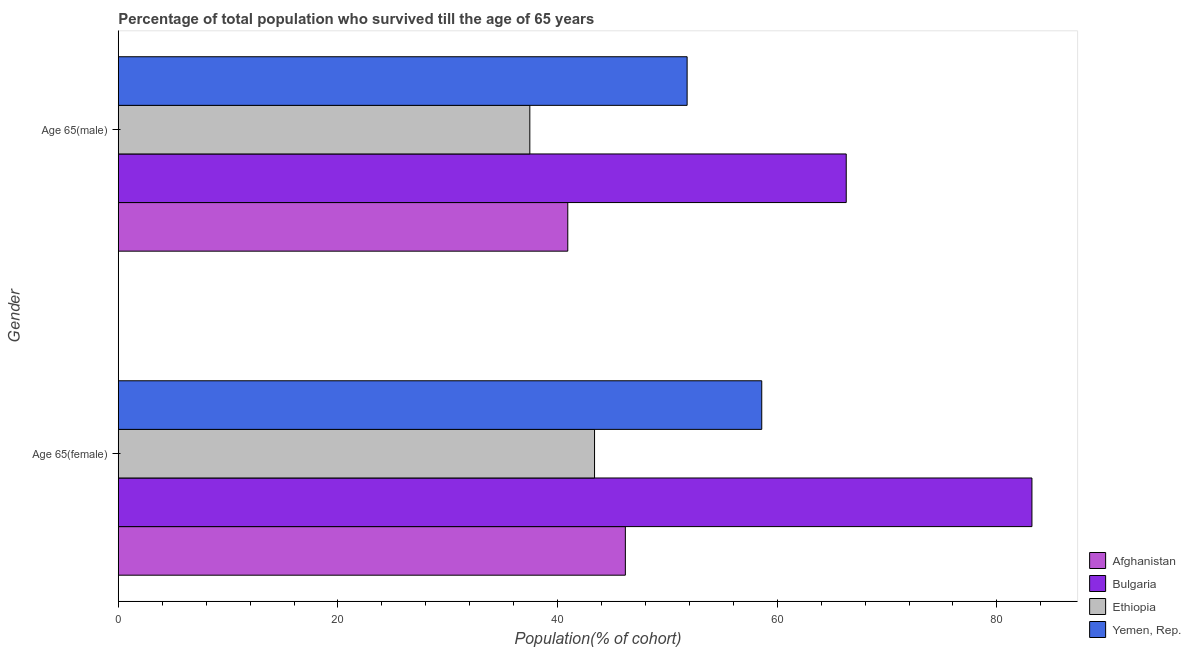How many bars are there on the 1st tick from the top?
Provide a short and direct response. 4. What is the label of the 1st group of bars from the top?
Provide a succinct answer. Age 65(male). What is the percentage of male population who survived till age of 65 in Yemen, Rep.?
Offer a very short reply. 51.8. Across all countries, what is the maximum percentage of male population who survived till age of 65?
Keep it short and to the point. 66.28. Across all countries, what is the minimum percentage of male population who survived till age of 65?
Provide a short and direct response. 37.47. In which country was the percentage of male population who survived till age of 65 minimum?
Keep it short and to the point. Ethiopia. What is the total percentage of male population who survived till age of 65 in the graph?
Offer a very short reply. 196.48. What is the difference between the percentage of male population who survived till age of 65 in Yemen, Rep. and that in Afghanistan?
Provide a succinct answer. 10.87. What is the difference between the percentage of male population who survived till age of 65 in Yemen, Rep. and the percentage of female population who survived till age of 65 in Bulgaria?
Keep it short and to the point. -31.4. What is the average percentage of female population who survived till age of 65 per country?
Offer a terse response. 57.83. What is the difference between the percentage of female population who survived till age of 65 and percentage of male population who survived till age of 65 in Yemen, Rep.?
Your answer should be compact. 6.8. What is the ratio of the percentage of male population who survived till age of 65 in Yemen, Rep. to that in Afghanistan?
Offer a terse response. 1.27. In how many countries, is the percentage of female population who survived till age of 65 greater than the average percentage of female population who survived till age of 65 taken over all countries?
Your answer should be compact. 2. What does the 1st bar from the top in Age 65(male) represents?
Provide a succinct answer. Yemen, Rep. What does the 4th bar from the bottom in Age 65(female) represents?
Make the answer very short. Yemen, Rep. How many bars are there?
Your answer should be very brief. 8. Are all the bars in the graph horizontal?
Keep it short and to the point. Yes. How many countries are there in the graph?
Provide a short and direct response. 4. What is the difference between two consecutive major ticks on the X-axis?
Provide a succinct answer. 20. Does the graph contain any zero values?
Your response must be concise. No. Does the graph contain grids?
Offer a very short reply. No. Where does the legend appear in the graph?
Your response must be concise. Bottom right. How many legend labels are there?
Offer a very short reply. 4. How are the legend labels stacked?
Your answer should be compact. Vertical. What is the title of the graph?
Your answer should be compact. Percentage of total population who survived till the age of 65 years. What is the label or title of the X-axis?
Ensure brevity in your answer.  Population(% of cohort). What is the Population(% of cohort) in Afghanistan in Age 65(female)?
Provide a succinct answer. 46.17. What is the Population(% of cohort) in Bulgaria in Age 65(female)?
Give a very brief answer. 83.19. What is the Population(% of cohort) in Ethiopia in Age 65(female)?
Your response must be concise. 43.37. What is the Population(% of cohort) in Yemen, Rep. in Age 65(female)?
Your response must be concise. 58.59. What is the Population(% of cohort) of Afghanistan in Age 65(male)?
Provide a short and direct response. 40.93. What is the Population(% of cohort) in Bulgaria in Age 65(male)?
Ensure brevity in your answer.  66.28. What is the Population(% of cohort) of Ethiopia in Age 65(male)?
Give a very brief answer. 37.47. What is the Population(% of cohort) in Yemen, Rep. in Age 65(male)?
Ensure brevity in your answer.  51.8. Across all Gender, what is the maximum Population(% of cohort) in Afghanistan?
Provide a short and direct response. 46.17. Across all Gender, what is the maximum Population(% of cohort) of Bulgaria?
Give a very brief answer. 83.19. Across all Gender, what is the maximum Population(% of cohort) of Ethiopia?
Your response must be concise. 43.37. Across all Gender, what is the maximum Population(% of cohort) of Yemen, Rep.?
Your response must be concise. 58.59. Across all Gender, what is the minimum Population(% of cohort) of Afghanistan?
Keep it short and to the point. 40.93. Across all Gender, what is the minimum Population(% of cohort) in Bulgaria?
Offer a very short reply. 66.28. Across all Gender, what is the minimum Population(% of cohort) in Ethiopia?
Keep it short and to the point. 37.47. Across all Gender, what is the minimum Population(% of cohort) in Yemen, Rep.?
Ensure brevity in your answer.  51.8. What is the total Population(% of cohort) of Afghanistan in the graph?
Give a very brief answer. 87.1. What is the total Population(% of cohort) of Bulgaria in the graph?
Your answer should be compact. 149.48. What is the total Population(% of cohort) of Ethiopia in the graph?
Provide a short and direct response. 80.84. What is the total Population(% of cohort) of Yemen, Rep. in the graph?
Offer a terse response. 110.39. What is the difference between the Population(% of cohort) in Afghanistan in Age 65(female) and that in Age 65(male)?
Your answer should be very brief. 5.24. What is the difference between the Population(% of cohort) of Bulgaria in Age 65(female) and that in Age 65(male)?
Your answer should be very brief. 16.91. What is the difference between the Population(% of cohort) of Ethiopia in Age 65(female) and that in Age 65(male)?
Your answer should be compact. 5.89. What is the difference between the Population(% of cohort) of Yemen, Rep. in Age 65(female) and that in Age 65(male)?
Ensure brevity in your answer.  6.8. What is the difference between the Population(% of cohort) of Afghanistan in Age 65(female) and the Population(% of cohort) of Bulgaria in Age 65(male)?
Offer a very short reply. -20.11. What is the difference between the Population(% of cohort) of Afghanistan in Age 65(female) and the Population(% of cohort) of Ethiopia in Age 65(male)?
Offer a terse response. 8.7. What is the difference between the Population(% of cohort) in Afghanistan in Age 65(female) and the Population(% of cohort) in Yemen, Rep. in Age 65(male)?
Offer a very short reply. -5.62. What is the difference between the Population(% of cohort) in Bulgaria in Age 65(female) and the Population(% of cohort) in Ethiopia in Age 65(male)?
Keep it short and to the point. 45.72. What is the difference between the Population(% of cohort) of Bulgaria in Age 65(female) and the Population(% of cohort) of Yemen, Rep. in Age 65(male)?
Provide a succinct answer. 31.4. What is the difference between the Population(% of cohort) in Ethiopia in Age 65(female) and the Population(% of cohort) in Yemen, Rep. in Age 65(male)?
Ensure brevity in your answer.  -8.43. What is the average Population(% of cohort) of Afghanistan per Gender?
Keep it short and to the point. 43.55. What is the average Population(% of cohort) of Bulgaria per Gender?
Your answer should be compact. 74.74. What is the average Population(% of cohort) of Ethiopia per Gender?
Keep it short and to the point. 40.42. What is the average Population(% of cohort) in Yemen, Rep. per Gender?
Your answer should be very brief. 55.19. What is the difference between the Population(% of cohort) of Afghanistan and Population(% of cohort) of Bulgaria in Age 65(female)?
Offer a very short reply. -37.02. What is the difference between the Population(% of cohort) of Afghanistan and Population(% of cohort) of Ethiopia in Age 65(female)?
Your answer should be very brief. 2.8. What is the difference between the Population(% of cohort) in Afghanistan and Population(% of cohort) in Yemen, Rep. in Age 65(female)?
Your answer should be compact. -12.42. What is the difference between the Population(% of cohort) in Bulgaria and Population(% of cohort) in Ethiopia in Age 65(female)?
Provide a succinct answer. 39.83. What is the difference between the Population(% of cohort) of Bulgaria and Population(% of cohort) of Yemen, Rep. in Age 65(female)?
Keep it short and to the point. 24.6. What is the difference between the Population(% of cohort) in Ethiopia and Population(% of cohort) in Yemen, Rep. in Age 65(female)?
Provide a succinct answer. -15.22. What is the difference between the Population(% of cohort) in Afghanistan and Population(% of cohort) in Bulgaria in Age 65(male)?
Your answer should be compact. -25.36. What is the difference between the Population(% of cohort) of Afghanistan and Population(% of cohort) of Ethiopia in Age 65(male)?
Give a very brief answer. 3.46. What is the difference between the Population(% of cohort) of Afghanistan and Population(% of cohort) of Yemen, Rep. in Age 65(male)?
Give a very brief answer. -10.87. What is the difference between the Population(% of cohort) of Bulgaria and Population(% of cohort) of Ethiopia in Age 65(male)?
Your answer should be very brief. 28.81. What is the difference between the Population(% of cohort) in Bulgaria and Population(% of cohort) in Yemen, Rep. in Age 65(male)?
Your answer should be compact. 14.49. What is the difference between the Population(% of cohort) of Ethiopia and Population(% of cohort) of Yemen, Rep. in Age 65(male)?
Your answer should be very brief. -14.32. What is the ratio of the Population(% of cohort) in Afghanistan in Age 65(female) to that in Age 65(male)?
Your response must be concise. 1.13. What is the ratio of the Population(% of cohort) in Bulgaria in Age 65(female) to that in Age 65(male)?
Your answer should be compact. 1.26. What is the ratio of the Population(% of cohort) in Ethiopia in Age 65(female) to that in Age 65(male)?
Provide a short and direct response. 1.16. What is the ratio of the Population(% of cohort) in Yemen, Rep. in Age 65(female) to that in Age 65(male)?
Provide a short and direct response. 1.13. What is the difference between the highest and the second highest Population(% of cohort) of Afghanistan?
Make the answer very short. 5.24. What is the difference between the highest and the second highest Population(% of cohort) in Bulgaria?
Make the answer very short. 16.91. What is the difference between the highest and the second highest Population(% of cohort) of Ethiopia?
Your response must be concise. 5.89. What is the difference between the highest and the second highest Population(% of cohort) in Yemen, Rep.?
Your answer should be very brief. 6.8. What is the difference between the highest and the lowest Population(% of cohort) of Afghanistan?
Offer a very short reply. 5.24. What is the difference between the highest and the lowest Population(% of cohort) of Bulgaria?
Your answer should be compact. 16.91. What is the difference between the highest and the lowest Population(% of cohort) of Ethiopia?
Your response must be concise. 5.89. What is the difference between the highest and the lowest Population(% of cohort) in Yemen, Rep.?
Give a very brief answer. 6.8. 